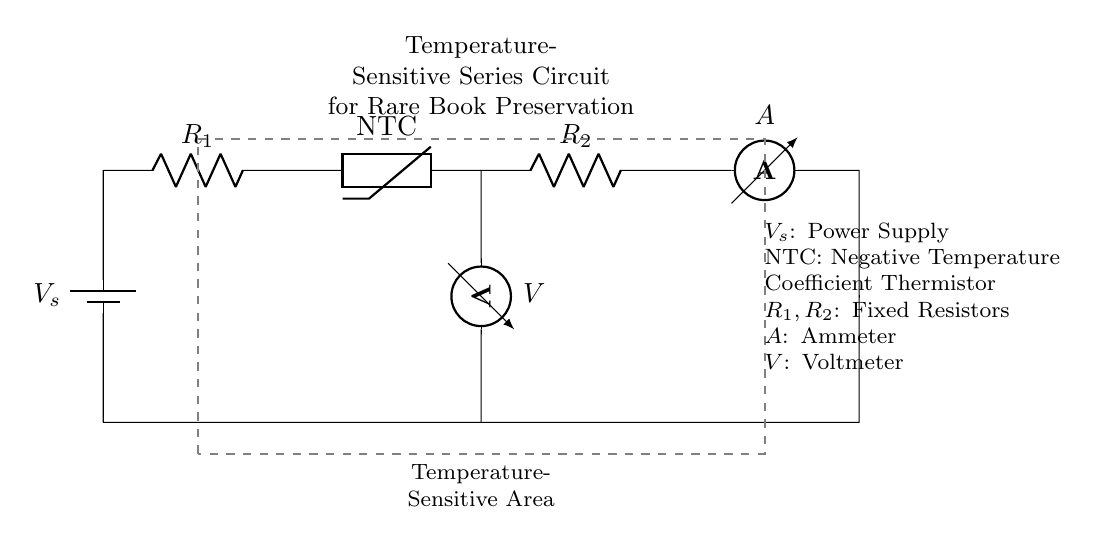What type of thermistor is used in this circuit? The circuit depicts a negative temperature coefficient (NTC) thermistor, which means its resistance decreases as temperature increases. This is clearly labeled next to the thermistor symbol in the circuit.
Answer: NTC What is the function of the ammeter in this circuit? The ammeter measures the current flowing through the circuit, and it is connected in series with the other components. This is evident from its position between the second resistor and the ground connection.
Answer: Measure current How many resistors are present in this circuit? The circuit contains two resistors: one is labeled R1 and the other R2. Counting these components shows that there are two fixed resistors in this temperature-sensitive circuit.
Answer: Two What happens to the resistance of an NTC thermistor as temperature rises? As the temperature increases, the resistance of the NTC thermistor decreases. This property allows the circuit to monitor environmental conditions, specifically recognizing changes in temperature by detecting the change in resistance.
Answer: Decreases What is the role of the power supply in this circuit? The power supply (labeled as Vs) provides the necessary voltage for the circuit to function. It establishes the potential difference needed for current to flow through the components, allowing the circuit to operate.
Answer: Provides voltage 